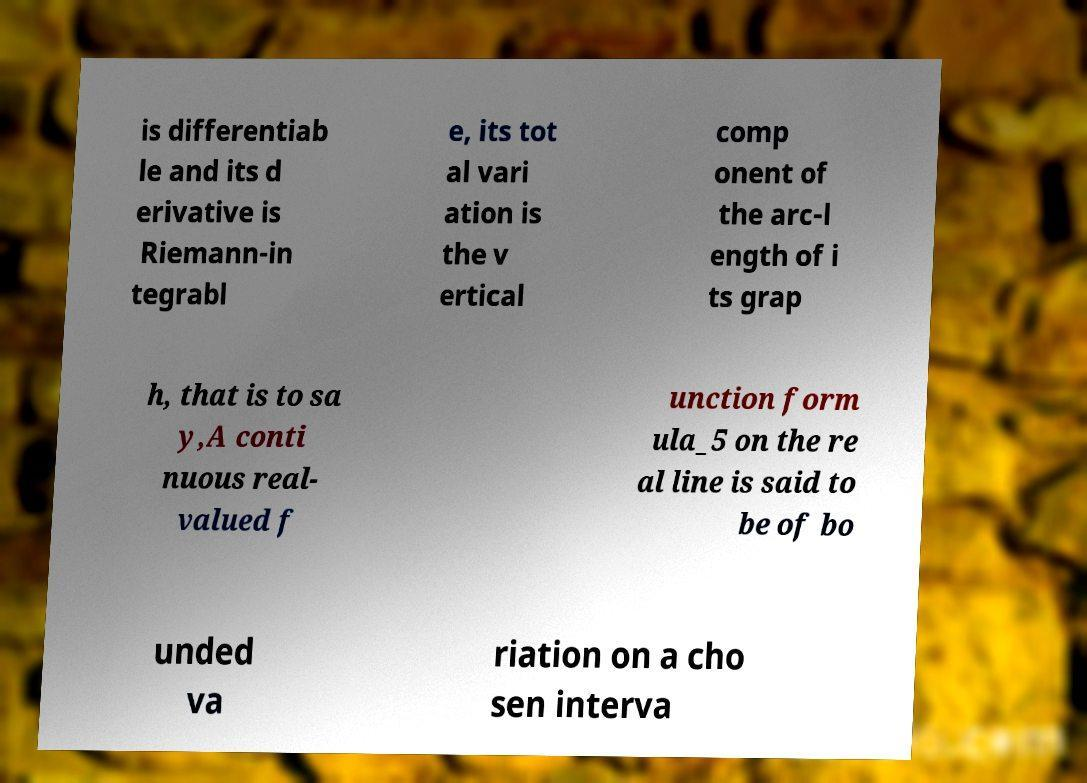I need the written content from this picture converted into text. Can you do that? is differentiab le and its d erivative is Riemann-in tegrabl e, its tot al vari ation is the v ertical comp onent of the arc-l ength of i ts grap h, that is to sa y,A conti nuous real- valued f unction form ula_5 on the re al line is said to be of bo unded va riation on a cho sen interva 